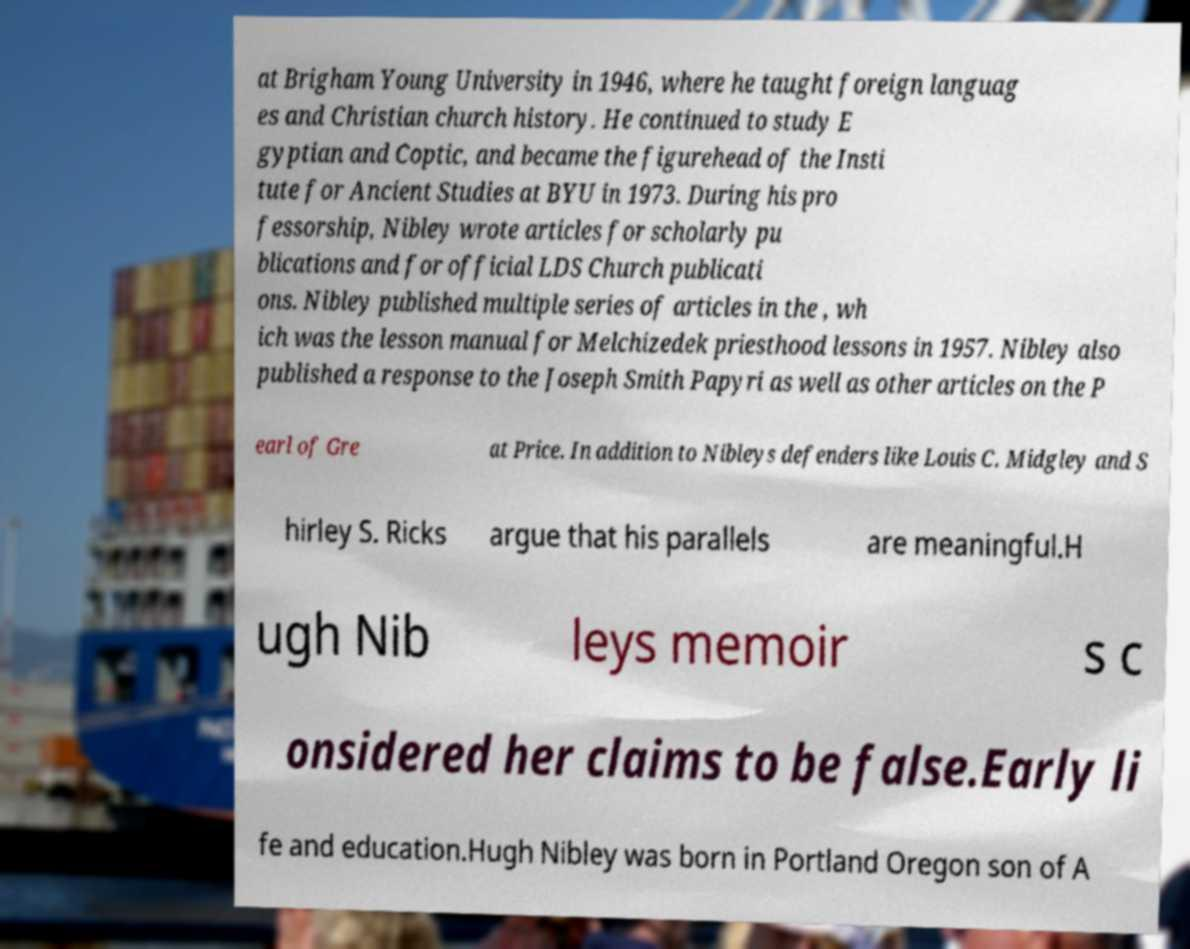Please read and relay the text visible in this image. What does it say? at Brigham Young University in 1946, where he taught foreign languag es and Christian church history. He continued to study E gyptian and Coptic, and became the figurehead of the Insti tute for Ancient Studies at BYU in 1973. During his pro fessorship, Nibley wrote articles for scholarly pu blications and for official LDS Church publicati ons. Nibley published multiple series of articles in the , wh ich was the lesson manual for Melchizedek priesthood lessons in 1957. Nibley also published a response to the Joseph Smith Papyri as well as other articles on the P earl of Gre at Price. In addition to Nibleys defenders like Louis C. Midgley and S hirley S. Ricks argue that his parallels are meaningful.H ugh Nib leys memoir s c onsidered her claims to be false.Early li fe and education.Hugh Nibley was born in Portland Oregon son of A 